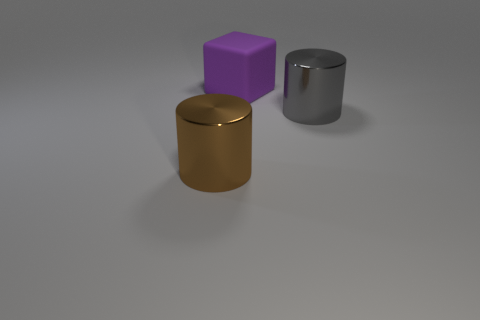What does the purple cube's surface texture suggest about the material it is made from? The purple cube in the image displays a matte surface with a distinct lack of reflection, which could suggest it is made from a non-metallic material, possibly a type of plastic or painted wood. 